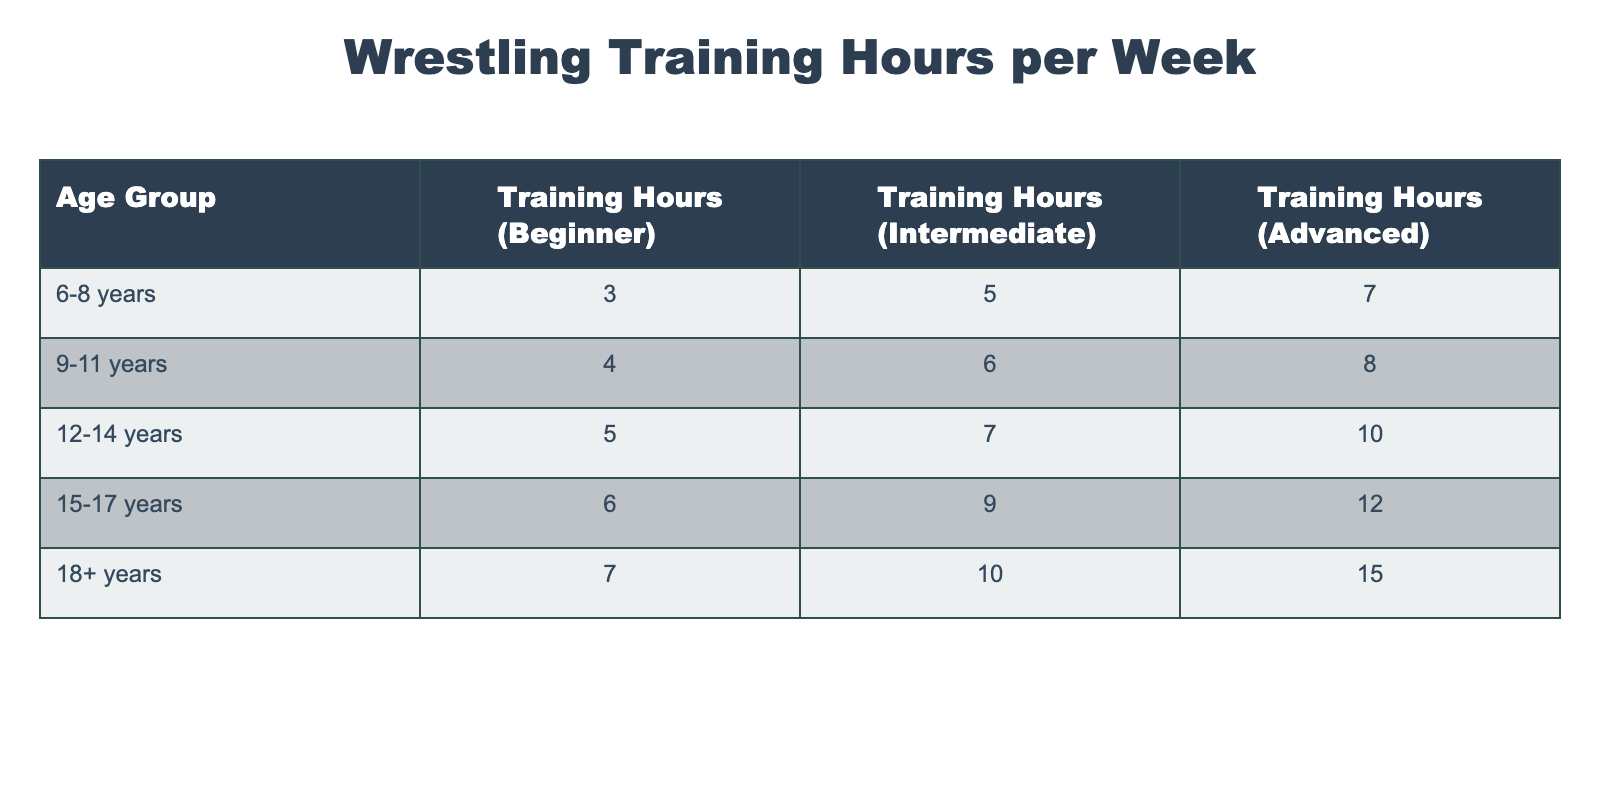What are the training hours for beginners in the 12-14 years age group? In the table, under the column "Training Hours (Beginner)", I can find the row for the "12-14 years" age group, which shows the value of 5 hours.
Answer: 5 Which age group has the highest training hours for advanced wrestlers? Looking under the "Training Hours (Advanced)" column, the maximum value occurs in the "18+ years" age group, which has 15 hours listed.
Answer: 18+ years What is the difference in training hours between beginners and advanced wrestlers in the 9-11 years age group? For the "9-11 years" age group, beginners train for 4 hours and advanced wrestlers train for 8 hours. The difference is 8 - 4 = 4 hours.
Answer: 4 Is it true that the training hours for intermediate wrestlers increase with age? Observing the "Training Hours (Intermediate)" column, I see a trend where each successive age group has increasing hours: 5, 6, 7, 9, and 10 hours. Therefore, it is true.
Answer: Yes What is the average training hour for advanced wrestlers across all age groups? I will first sum the advanced training hours for each age group: 7 + 8 + 10 + 12 + 15 = 52. There are 5 age groups, so the average is 52 / 5 = 10.4 hours.
Answer: 10.4 